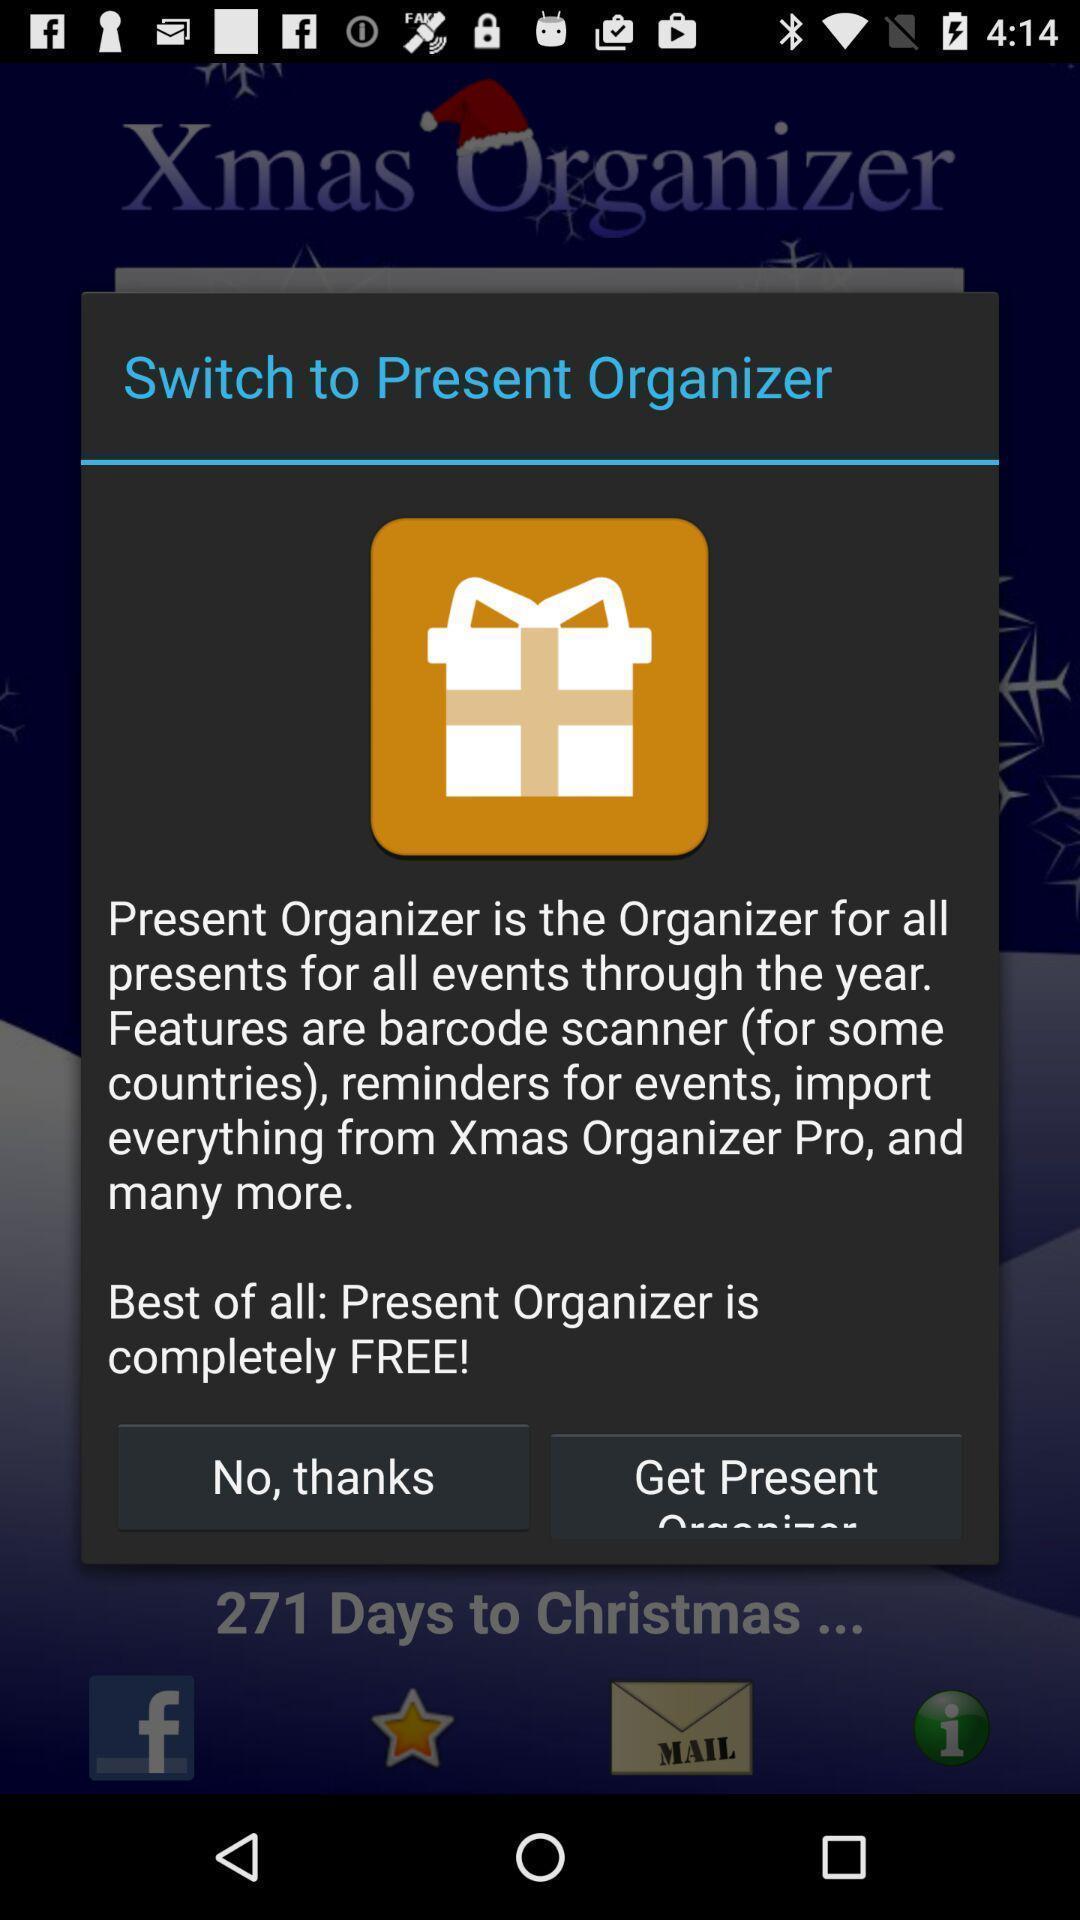What details can you identify in this image? Popup showing to switch to present organizer. 